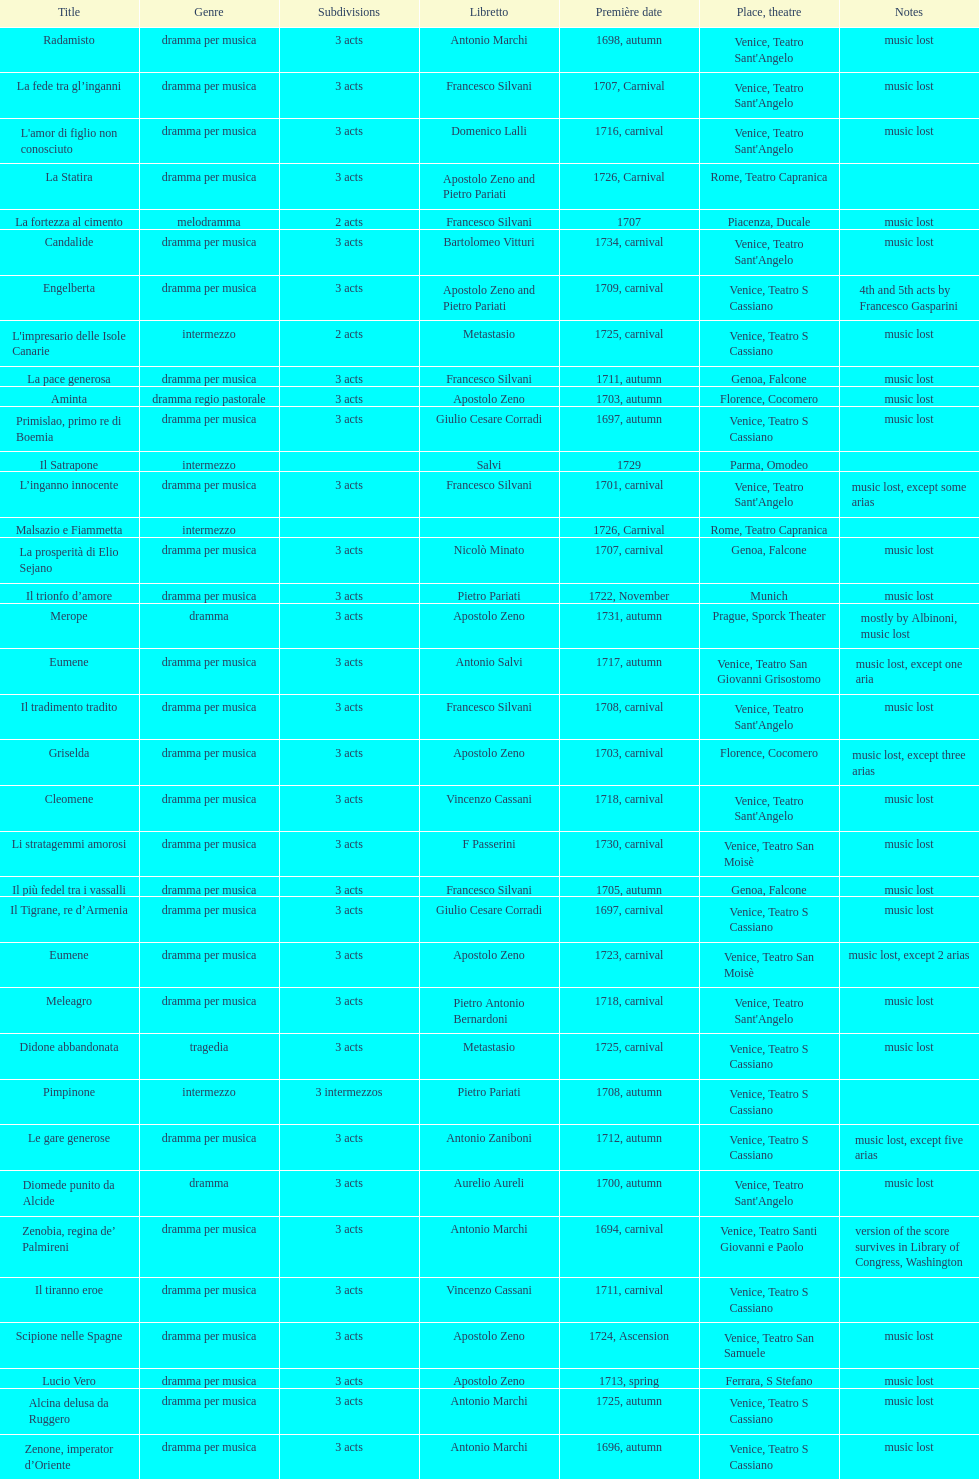Which opera has the most acts, la fortezza al cimento or astarto? Astarto. 